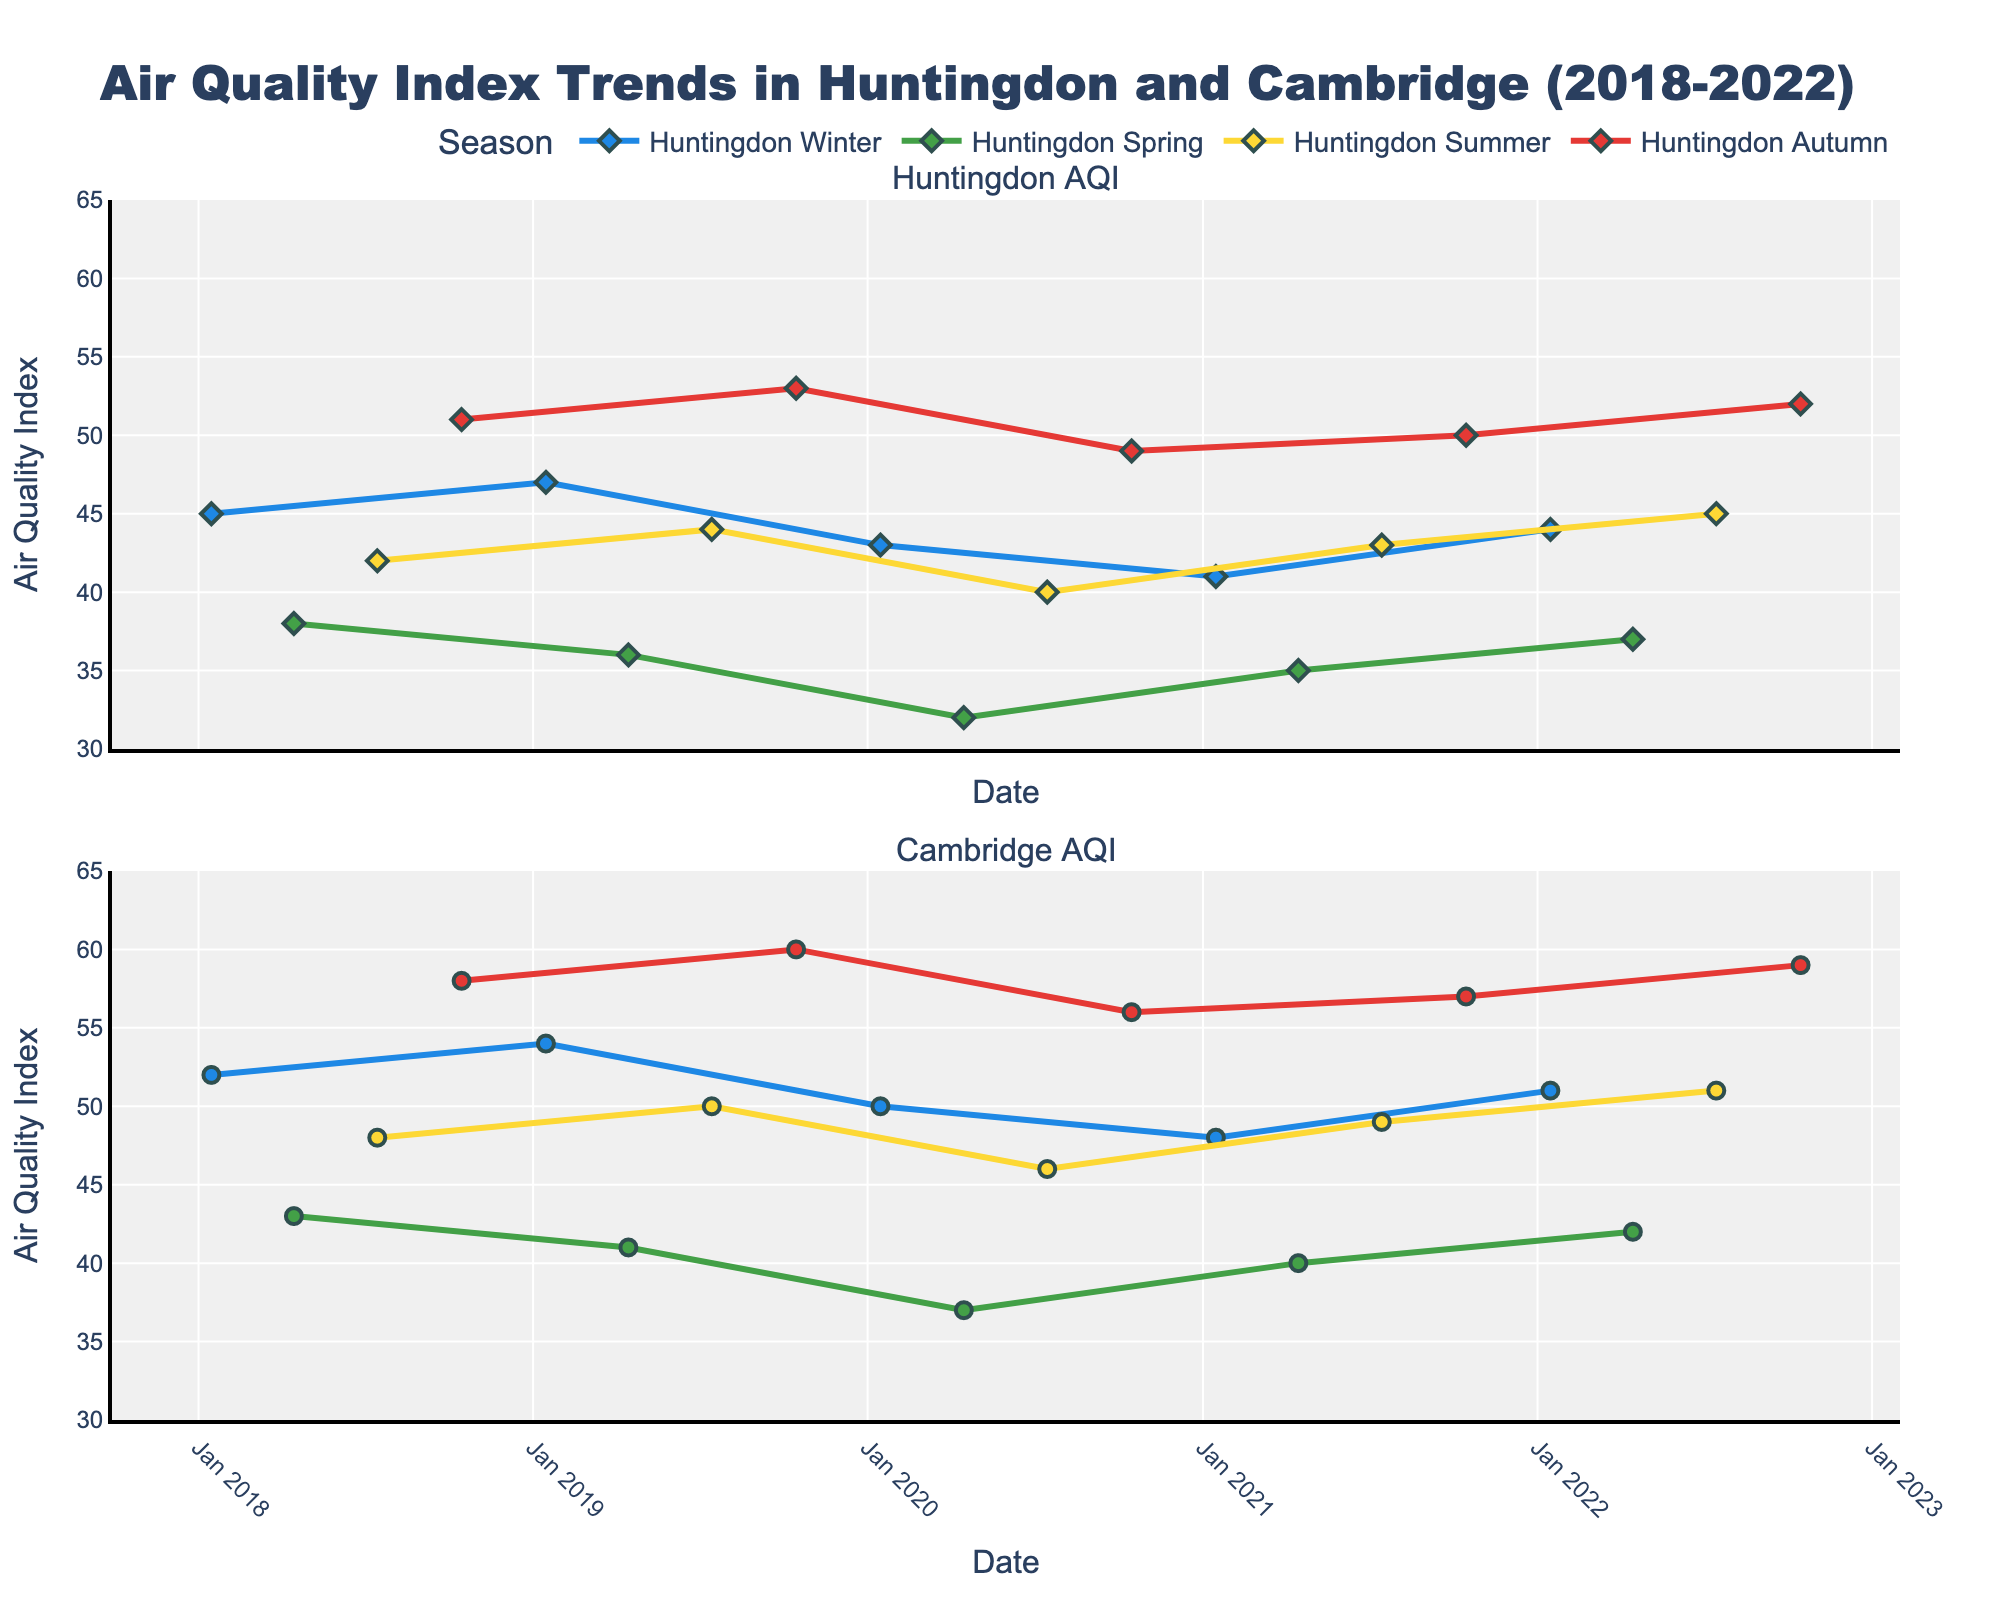What's the title of the figure? The title is found at the top center of the figure. It is bold and easily noticeable.
Answer: Air Quality Index Trends in Huntingdon and Cambridge (2018-2022) How many seasons are represented in the figure? The figure uses different colors for each season in the legend area, mentioning Winter, Spring, Summer, and Autumn.
Answer: Four Which season shows the highest AQI value for Huntingdon, and what is that value? By examining the upper subplot for Huntingdon, the highest point is reached in Autumn 2019 with a value of 53.
Answer: Autumn, 53 What season had the most consistent AQI values across both locations? Identifying consistency involves observing similar ranges for both locations in each subplot, noticing Spring across all years lies between 32-37 for Huntingdon and 37-43 for Cambridge.
Answer: Spring What is the average AQI value for Huntingdon in Winter? Adding values for Winter (45, 47, 43, 41, 44) results in 220, divided by 5 winters gives 44.
Answer: 44 Which location generally has higher AQI values during the summer season? Comparing similar symbols in both subplots for each summer, Cambridge values (48, 50, 46, 49, 51) exceed those in Huntingdon (42, 44, 40, 43, 45).
Answer: Cambridge What is the difference in AQI between Cambridge and Huntingdon during the Autumn of 2021? Subtract AQI of Huntingdon (50) from Cambridge (57) results in a difference of 7.
Answer: 7 Which season colors represent the highest and lowest AQI values in Cambridge? Identifying values in the lower subplot, the highest AQI (60) is in Autumn (color: red), and the lowest (37) occurs in Spring (color: green).
Answer: Red (Autumn), Green (Spring) How does the trend in AQI change from Winter 2020 to Winter 2021 in Huntingdon? Observe the progression in the upper subplot, showing a consistent decline from 43 in Winter 2020 to 41 in Winter 2021.
Answer: It decreases Between which years did Cambridge experience the largest drop in summer AQI? Comparing summer values (2018 - 48, 2019 - 50, 2020 - 46, 2021 - 49, 2022 - 51), the largest drop is between 2019 and 2020 (4 points).
Answer: 2019 to 2020 